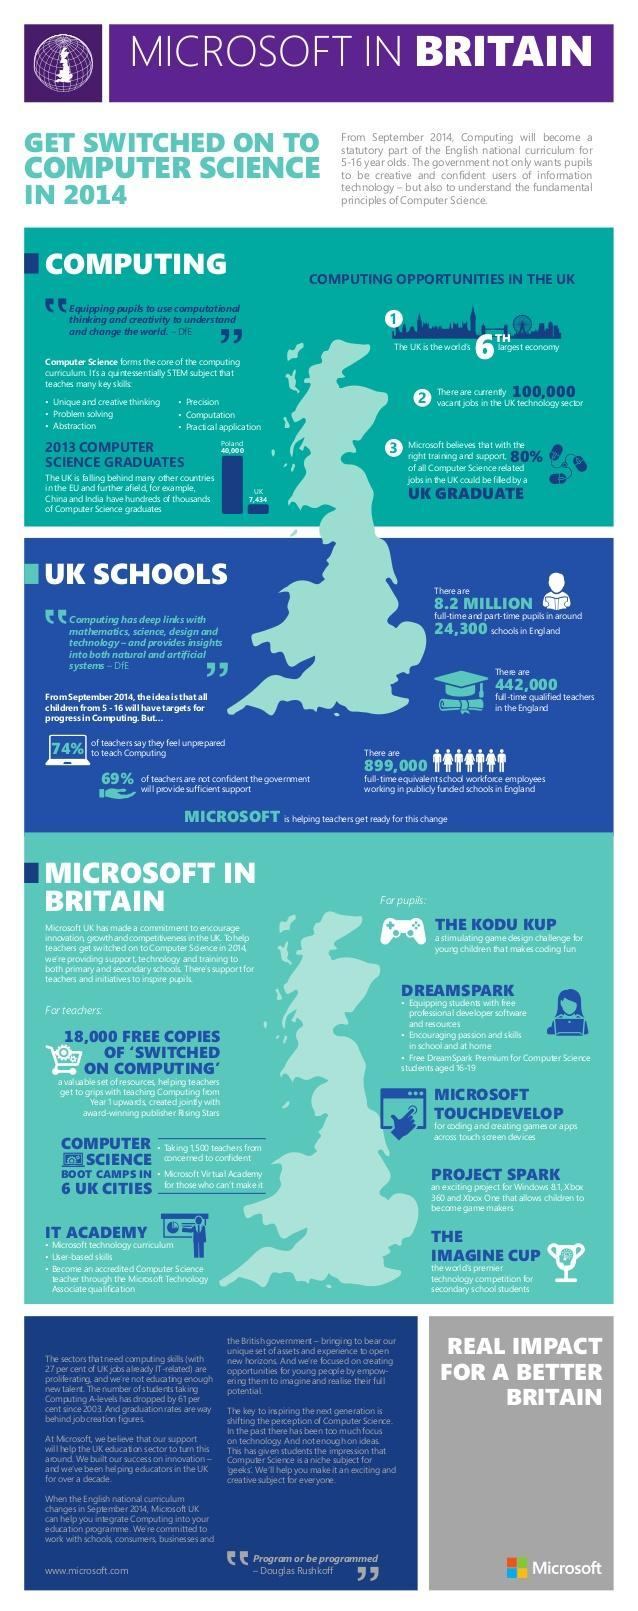How many main activities are Microsoft doing for the teachers in UK
Answer the question with a short phrase. 3 How many more computer science graduates does Poland have when compared to UK in 2013 32566 Where can you become an accredited Computer Science Bachelor IT Academy computing has links with which subjects mathematics, science, design and technology How pupils in and around schools in England 8.2 million how many vacant jobs in the UK technology sector 100,000 How many key skills does computer science teach 6 Where will children get free professional developer software and resources dreamspark 